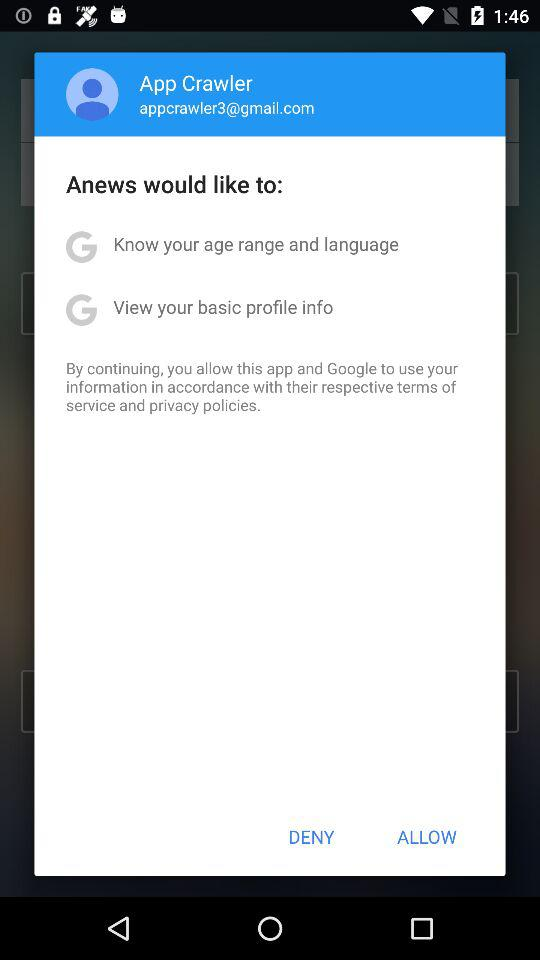What is the email address of the user? The email address of the user is appcrawler3@gmail.com. 